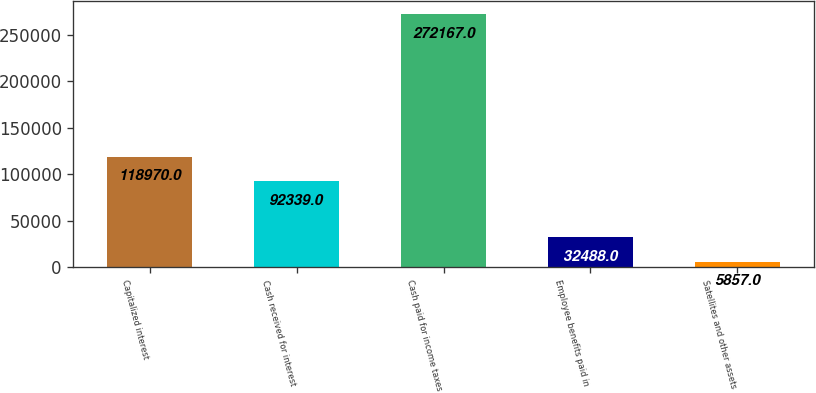Convert chart to OTSL. <chart><loc_0><loc_0><loc_500><loc_500><bar_chart><fcel>Capitalized interest<fcel>Cash received for interest<fcel>Cash paid for income taxes<fcel>Employee benefits paid in<fcel>Satellites and other assets<nl><fcel>118970<fcel>92339<fcel>272167<fcel>32488<fcel>5857<nl></chart> 